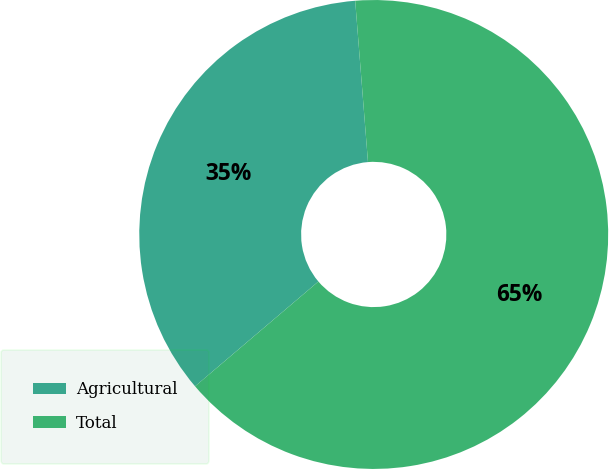Convert chart. <chart><loc_0><loc_0><loc_500><loc_500><pie_chart><fcel>Agricultural<fcel>Total<nl><fcel>34.95%<fcel>65.05%<nl></chart> 